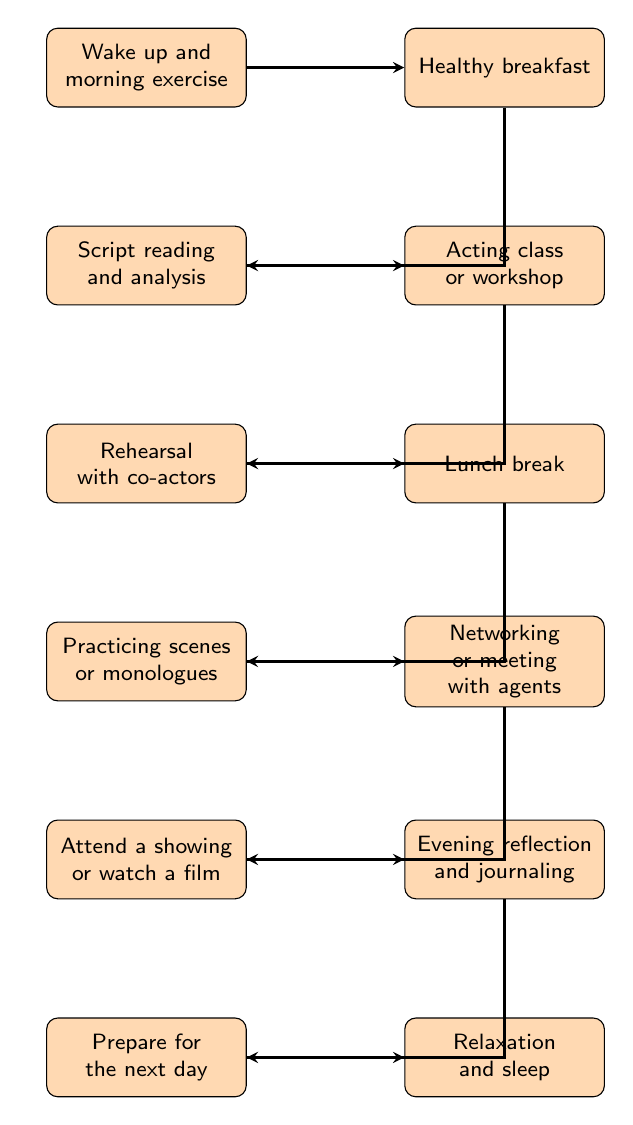What is the first activity listed in the diagram? The first node in the diagram is labeled "Wake up and morning exercise." Therefore, this is the activity that comes first in the daily routine of a working actor.
Answer: Wake up and morning exercise How many nodes are there in the diagram? The diagram contains a total of 12 nodes representing different activities, which can be counted directly from the list provided in the data section.
Answer: 12 What activity comes after "Healthy breakfast"? The node immediately following "Healthy breakfast" (second node) is "Script reading and analysis," which shows the next step in the actor's daily routine.
Answer: Script reading and analysis Which two activities are directly connected, involving a class or workshop? The edges show that "Acting class or workshop" follows "Script reading and analysis" and is directly connected to the rehearsal with co-actors. Thus, these two nodes demonstrate the sequence of involvement in learning and collaboration.
Answer: Acting class or workshop and Rehearsal with co-actors What is the last activity in the daily routine? According to the flow of the diagram, the last node which you arrive at is "Relaxation and sleep," marking the end of the daily schedule for a working actor.
Answer: Relaxation and sleep If an actor finishes "Networking or meeting with agents," what is the next activity? The sequence of activities shows that after "Networking or meeting with agents," the next activity is "Attend a showing or watch a film." This indicates what follows that networking effort in their daily routine.
Answer: Attend a showing or watch a film Which activity directly leads to the preparation for the next day? The node "Evening reflection and journaling" precedes "Prepare for the next day," indicating that this reflection time plays a crucial role in setting up for tomorrow. Thus, it is the direct predecessor.
Answer: Evening reflection and journaling What is the significance of the second node in the context of a working actor's routine? The second node "Healthy breakfast" highlights the importance of nutrition as a foundational part of an actor's daily routine, which emphasizes overall well-being and energy for subsequent activities.
Answer: Nutrition How are "Rehearsal with co-actors" and "Lunch break" connected in the diagram? The diagram shows that "Rehearsal with co-actors" leads directly to "Lunch break," indicating that after the rehearsal, the actor takes a break to refuel and recharge before continuing their day.
Answer: Sequential connection What role does "Practicing scenes or monologues" have in relation to networking activities? The diagram illustrates that "Practicing scenes or monologues" occurs before "Networking or meeting with agents," suggesting that these practice sessions are foundational for preparing the actor to effectively network and represent themselves or their work.
Answer: Foundational preparation 